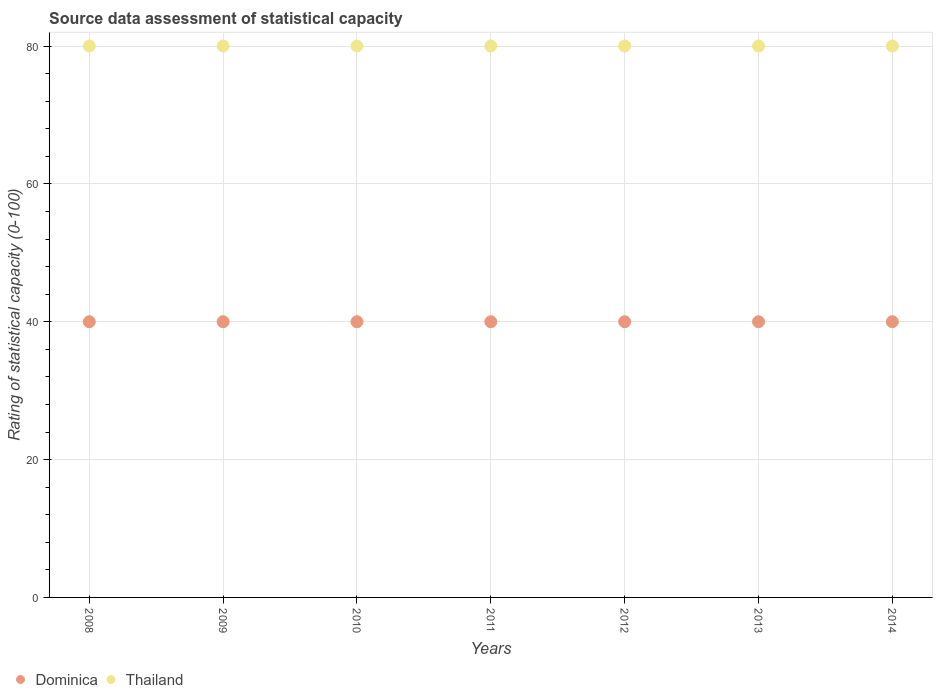How many different coloured dotlines are there?
Offer a very short reply. 2. Is the number of dotlines equal to the number of legend labels?
Offer a very short reply. Yes. Across all years, what is the maximum rating of statistical capacity in Thailand?
Provide a short and direct response. 80. Across all years, what is the minimum rating of statistical capacity in Thailand?
Your answer should be very brief. 80. What is the total rating of statistical capacity in Dominica in the graph?
Your answer should be very brief. 280. What is the difference between the rating of statistical capacity in Thailand in 2008 and that in 2009?
Keep it short and to the point. 0. What is the difference between the rating of statistical capacity in Dominica in 2011 and the rating of statistical capacity in Thailand in 2010?
Offer a terse response. -40. What is the average rating of statistical capacity in Thailand per year?
Your answer should be compact. 80. In how many years, is the rating of statistical capacity in Dominica greater than 44?
Provide a short and direct response. 0. Is the rating of statistical capacity in Thailand in 2009 less than that in 2010?
Give a very brief answer. No. Is the difference between the rating of statistical capacity in Thailand in 2009 and 2012 greater than the difference between the rating of statistical capacity in Dominica in 2009 and 2012?
Your answer should be compact. No. Is the sum of the rating of statistical capacity in Thailand in 2010 and 2011 greater than the maximum rating of statistical capacity in Dominica across all years?
Offer a very short reply. Yes. Is the rating of statistical capacity in Dominica strictly less than the rating of statistical capacity in Thailand over the years?
Your answer should be compact. Yes. How many years are there in the graph?
Keep it short and to the point. 7. Does the graph contain grids?
Ensure brevity in your answer.  Yes. How are the legend labels stacked?
Your answer should be very brief. Horizontal. What is the title of the graph?
Provide a succinct answer. Source data assessment of statistical capacity. Does "Uganda" appear as one of the legend labels in the graph?
Keep it short and to the point. No. What is the label or title of the Y-axis?
Your response must be concise. Rating of statistical capacity (0-100). What is the Rating of statistical capacity (0-100) of Dominica in 2008?
Ensure brevity in your answer.  40. What is the Rating of statistical capacity (0-100) in Thailand in 2008?
Your answer should be very brief. 80. What is the Rating of statistical capacity (0-100) in Thailand in 2009?
Ensure brevity in your answer.  80. What is the Rating of statistical capacity (0-100) in Dominica in 2010?
Make the answer very short. 40. What is the Rating of statistical capacity (0-100) of Dominica in 2013?
Ensure brevity in your answer.  40. What is the Rating of statistical capacity (0-100) in Dominica in 2014?
Provide a succinct answer. 40. What is the Rating of statistical capacity (0-100) in Thailand in 2014?
Make the answer very short. 80. Across all years, what is the minimum Rating of statistical capacity (0-100) of Dominica?
Provide a short and direct response. 40. Across all years, what is the minimum Rating of statistical capacity (0-100) in Thailand?
Provide a short and direct response. 80. What is the total Rating of statistical capacity (0-100) in Dominica in the graph?
Your answer should be very brief. 280. What is the total Rating of statistical capacity (0-100) of Thailand in the graph?
Your answer should be compact. 560. What is the difference between the Rating of statistical capacity (0-100) of Dominica in 2008 and that in 2009?
Ensure brevity in your answer.  0. What is the difference between the Rating of statistical capacity (0-100) in Thailand in 2008 and that in 2009?
Offer a terse response. 0. What is the difference between the Rating of statistical capacity (0-100) of Dominica in 2008 and that in 2011?
Give a very brief answer. 0. What is the difference between the Rating of statistical capacity (0-100) in Dominica in 2008 and that in 2012?
Your answer should be very brief. 0. What is the difference between the Rating of statistical capacity (0-100) in Thailand in 2008 and that in 2012?
Keep it short and to the point. 0. What is the difference between the Rating of statistical capacity (0-100) of Dominica in 2008 and that in 2013?
Provide a short and direct response. 0. What is the difference between the Rating of statistical capacity (0-100) of Dominica in 2008 and that in 2014?
Ensure brevity in your answer.  0. What is the difference between the Rating of statistical capacity (0-100) in Dominica in 2009 and that in 2011?
Give a very brief answer. 0. What is the difference between the Rating of statistical capacity (0-100) in Dominica in 2009 and that in 2012?
Offer a very short reply. 0. What is the difference between the Rating of statistical capacity (0-100) of Thailand in 2009 and that in 2012?
Offer a very short reply. 0. What is the difference between the Rating of statistical capacity (0-100) in Thailand in 2010 and that in 2012?
Offer a terse response. 0. What is the difference between the Rating of statistical capacity (0-100) in Dominica in 2010 and that in 2014?
Your answer should be compact. 0. What is the difference between the Rating of statistical capacity (0-100) of Dominica in 2011 and that in 2012?
Provide a short and direct response. 0. What is the difference between the Rating of statistical capacity (0-100) in Thailand in 2011 and that in 2013?
Keep it short and to the point. 0. What is the difference between the Rating of statistical capacity (0-100) in Dominica in 2012 and that in 2013?
Offer a very short reply. 0. What is the difference between the Rating of statistical capacity (0-100) in Thailand in 2012 and that in 2013?
Keep it short and to the point. 0. What is the difference between the Rating of statistical capacity (0-100) of Dominica in 2012 and that in 2014?
Make the answer very short. 0. What is the difference between the Rating of statistical capacity (0-100) in Dominica in 2008 and the Rating of statistical capacity (0-100) in Thailand in 2010?
Make the answer very short. -40. What is the difference between the Rating of statistical capacity (0-100) of Dominica in 2008 and the Rating of statistical capacity (0-100) of Thailand in 2013?
Provide a short and direct response. -40. What is the difference between the Rating of statistical capacity (0-100) of Dominica in 2008 and the Rating of statistical capacity (0-100) of Thailand in 2014?
Offer a very short reply. -40. What is the difference between the Rating of statistical capacity (0-100) of Dominica in 2009 and the Rating of statistical capacity (0-100) of Thailand in 2010?
Provide a short and direct response. -40. What is the difference between the Rating of statistical capacity (0-100) of Dominica in 2009 and the Rating of statistical capacity (0-100) of Thailand in 2013?
Your response must be concise. -40. What is the difference between the Rating of statistical capacity (0-100) of Dominica in 2009 and the Rating of statistical capacity (0-100) of Thailand in 2014?
Provide a short and direct response. -40. What is the difference between the Rating of statistical capacity (0-100) in Dominica in 2010 and the Rating of statistical capacity (0-100) in Thailand in 2012?
Your response must be concise. -40. What is the difference between the Rating of statistical capacity (0-100) in Dominica in 2010 and the Rating of statistical capacity (0-100) in Thailand in 2014?
Give a very brief answer. -40. What is the difference between the Rating of statistical capacity (0-100) of Dominica in 2011 and the Rating of statistical capacity (0-100) of Thailand in 2013?
Give a very brief answer. -40. What is the difference between the Rating of statistical capacity (0-100) in Dominica in 2011 and the Rating of statistical capacity (0-100) in Thailand in 2014?
Your answer should be compact. -40. What is the difference between the Rating of statistical capacity (0-100) in Dominica in 2012 and the Rating of statistical capacity (0-100) in Thailand in 2013?
Provide a short and direct response. -40. What is the difference between the Rating of statistical capacity (0-100) in Dominica in 2012 and the Rating of statistical capacity (0-100) in Thailand in 2014?
Your answer should be compact. -40. What is the difference between the Rating of statistical capacity (0-100) of Dominica in 2013 and the Rating of statistical capacity (0-100) of Thailand in 2014?
Give a very brief answer. -40. In the year 2009, what is the difference between the Rating of statistical capacity (0-100) in Dominica and Rating of statistical capacity (0-100) in Thailand?
Keep it short and to the point. -40. In the year 2010, what is the difference between the Rating of statistical capacity (0-100) of Dominica and Rating of statistical capacity (0-100) of Thailand?
Make the answer very short. -40. In the year 2011, what is the difference between the Rating of statistical capacity (0-100) of Dominica and Rating of statistical capacity (0-100) of Thailand?
Offer a very short reply. -40. In the year 2014, what is the difference between the Rating of statistical capacity (0-100) of Dominica and Rating of statistical capacity (0-100) of Thailand?
Give a very brief answer. -40. What is the ratio of the Rating of statistical capacity (0-100) of Dominica in 2008 to that in 2010?
Your response must be concise. 1. What is the ratio of the Rating of statistical capacity (0-100) of Thailand in 2008 to that in 2010?
Your response must be concise. 1. What is the ratio of the Rating of statistical capacity (0-100) in Dominica in 2008 to that in 2012?
Your answer should be very brief. 1. What is the ratio of the Rating of statistical capacity (0-100) in Thailand in 2008 to that in 2012?
Keep it short and to the point. 1. What is the ratio of the Rating of statistical capacity (0-100) in Thailand in 2008 to that in 2013?
Give a very brief answer. 1. What is the ratio of the Rating of statistical capacity (0-100) of Dominica in 2008 to that in 2014?
Make the answer very short. 1. What is the ratio of the Rating of statistical capacity (0-100) in Thailand in 2008 to that in 2014?
Your answer should be very brief. 1. What is the ratio of the Rating of statistical capacity (0-100) of Thailand in 2009 to that in 2010?
Make the answer very short. 1. What is the ratio of the Rating of statistical capacity (0-100) of Dominica in 2009 to that in 2012?
Offer a terse response. 1. What is the ratio of the Rating of statistical capacity (0-100) in Thailand in 2009 to that in 2012?
Keep it short and to the point. 1. What is the ratio of the Rating of statistical capacity (0-100) in Thailand in 2010 to that in 2012?
Give a very brief answer. 1. What is the ratio of the Rating of statistical capacity (0-100) in Thailand in 2010 to that in 2013?
Keep it short and to the point. 1. What is the ratio of the Rating of statistical capacity (0-100) in Thailand in 2010 to that in 2014?
Your answer should be compact. 1. What is the ratio of the Rating of statistical capacity (0-100) in Dominica in 2011 to that in 2013?
Offer a very short reply. 1. What is the ratio of the Rating of statistical capacity (0-100) in Thailand in 2011 to that in 2013?
Your answer should be very brief. 1. What is the ratio of the Rating of statistical capacity (0-100) in Thailand in 2011 to that in 2014?
Provide a short and direct response. 1. What is the ratio of the Rating of statistical capacity (0-100) of Thailand in 2012 to that in 2013?
Give a very brief answer. 1. What is the ratio of the Rating of statistical capacity (0-100) of Dominica in 2012 to that in 2014?
Your answer should be compact. 1. What is the ratio of the Rating of statistical capacity (0-100) in Thailand in 2012 to that in 2014?
Make the answer very short. 1. What is the ratio of the Rating of statistical capacity (0-100) in Dominica in 2013 to that in 2014?
Give a very brief answer. 1. What is the difference between the highest and the second highest Rating of statistical capacity (0-100) of Thailand?
Make the answer very short. 0. What is the difference between the highest and the lowest Rating of statistical capacity (0-100) of Dominica?
Ensure brevity in your answer.  0. 